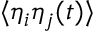<formula> <loc_0><loc_0><loc_500><loc_500>\langle \eta _ { i } \eta _ { j } ( t ) \rangle</formula> 